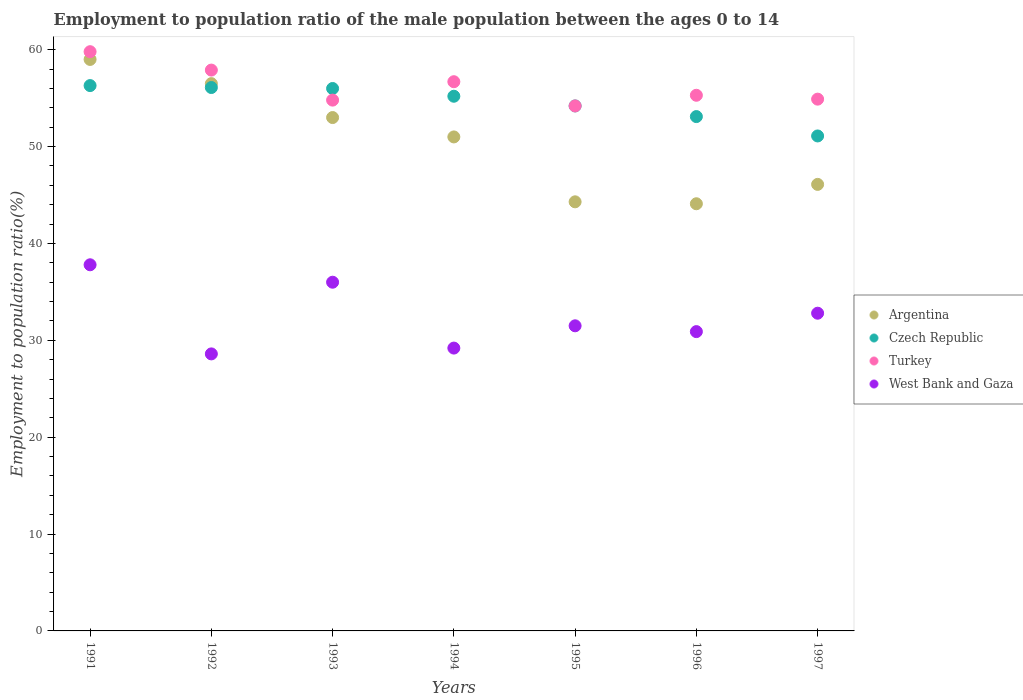How many different coloured dotlines are there?
Your answer should be compact. 4. Is the number of dotlines equal to the number of legend labels?
Give a very brief answer. Yes. What is the employment to population ratio in Turkey in 1996?
Your answer should be compact. 55.3. Across all years, what is the maximum employment to population ratio in Turkey?
Ensure brevity in your answer.  59.8. Across all years, what is the minimum employment to population ratio in Argentina?
Your answer should be compact. 44.1. In which year was the employment to population ratio in Turkey maximum?
Provide a succinct answer. 1991. What is the total employment to population ratio in Turkey in the graph?
Offer a terse response. 393.6. What is the difference between the employment to population ratio in Czech Republic in 1993 and the employment to population ratio in Turkey in 1995?
Offer a terse response. 1.8. What is the average employment to population ratio in Czech Republic per year?
Provide a succinct answer. 54.57. In the year 1996, what is the difference between the employment to population ratio in Czech Republic and employment to population ratio in West Bank and Gaza?
Offer a very short reply. 22.2. What is the ratio of the employment to population ratio in West Bank and Gaza in 1991 to that in 1992?
Your response must be concise. 1.32. Is the employment to population ratio in Turkey in 1993 less than that in 1997?
Your response must be concise. Yes. What is the difference between the highest and the second highest employment to population ratio in Turkey?
Provide a succinct answer. 1.9. What is the difference between the highest and the lowest employment to population ratio in Turkey?
Provide a succinct answer. 5.6. In how many years, is the employment to population ratio in West Bank and Gaza greater than the average employment to population ratio in West Bank and Gaza taken over all years?
Your answer should be very brief. 3. Does the employment to population ratio in West Bank and Gaza monotonically increase over the years?
Keep it short and to the point. No. Is the employment to population ratio in West Bank and Gaza strictly greater than the employment to population ratio in Czech Republic over the years?
Your answer should be compact. No. Is the employment to population ratio in West Bank and Gaza strictly less than the employment to population ratio in Argentina over the years?
Ensure brevity in your answer.  Yes. How many years are there in the graph?
Your response must be concise. 7. Are the values on the major ticks of Y-axis written in scientific E-notation?
Offer a very short reply. No. Does the graph contain any zero values?
Make the answer very short. No. Does the graph contain grids?
Your answer should be compact. No. Where does the legend appear in the graph?
Make the answer very short. Center right. How many legend labels are there?
Provide a succinct answer. 4. How are the legend labels stacked?
Offer a very short reply. Vertical. What is the title of the graph?
Provide a short and direct response. Employment to population ratio of the male population between the ages 0 to 14. Does "Jordan" appear as one of the legend labels in the graph?
Give a very brief answer. No. What is the Employment to population ratio(%) of Argentina in 1991?
Your answer should be compact. 59. What is the Employment to population ratio(%) in Czech Republic in 1991?
Your response must be concise. 56.3. What is the Employment to population ratio(%) in Turkey in 1991?
Make the answer very short. 59.8. What is the Employment to population ratio(%) in West Bank and Gaza in 1991?
Give a very brief answer. 37.8. What is the Employment to population ratio(%) in Argentina in 1992?
Make the answer very short. 56.5. What is the Employment to population ratio(%) in Czech Republic in 1992?
Keep it short and to the point. 56.1. What is the Employment to population ratio(%) of Turkey in 1992?
Your response must be concise. 57.9. What is the Employment to population ratio(%) in West Bank and Gaza in 1992?
Provide a short and direct response. 28.6. What is the Employment to population ratio(%) of Argentina in 1993?
Make the answer very short. 53. What is the Employment to population ratio(%) of Turkey in 1993?
Give a very brief answer. 54.8. What is the Employment to population ratio(%) in West Bank and Gaza in 1993?
Your answer should be very brief. 36. What is the Employment to population ratio(%) in Czech Republic in 1994?
Ensure brevity in your answer.  55.2. What is the Employment to population ratio(%) of Turkey in 1994?
Offer a terse response. 56.7. What is the Employment to population ratio(%) of West Bank and Gaza in 1994?
Provide a short and direct response. 29.2. What is the Employment to population ratio(%) in Argentina in 1995?
Offer a very short reply. 44.3. What is the Employment to population ratio(%) in Czech Republic in 1995?
Keep it short and to the point. 54.2. What is the Employment to population ratio(%) of Turkey in 1995?
Ensure brevity in your answer.  54.2. What is the Employment to population ratio(%) of West Bank and Gaza in 1995?
Offer a terse response. 31.5. What is the Employment to population ratio(%) in Argentina in 1996?
Provide a succinct answer. 44.1. What is the Employment to population ratio(%) of Czech Republic in 1996?
Offer a terse response. 53.1. What is the Employment to population ratio(%) of Turkey in 1996?
Ensure brevity in your answer.  55.3. What is the Employment to population ratio(%) of West Bank and Gaza in 1996?
Provide a short and direct response. 30.9. What is the Employment to population ratio(%) of Argentina in 1997?
Offer a terse response. 46.1. What is the Employment to population ratio(%) of Czech Republic in 1997?
Ensure brevity in your answer.  51.1. What is the Employment to population ratio(%) in Turkey in 1997?
Offer a very short reply. 54.9. What is the Employment to population ratio(%) of West Bank and Gaza in 1997?
Provide a short and direct response. 32.8. Across all years, what is the maximum Employment to population ratio(%) in Czech Republic?
Provide a short and direct response. 56.3. Across all years, what is the maximum Employment to population ratio(%) of Turkey?
Your answer should be compact. 59.8. Across all years, what is the maximum Employment to population ratio(%) of West Bank and Gaza?
Keep it short and to the point. 37.8. Across all years, what is the minimum Employment to population ratio(%) in Argentina?
Ensure brevity in your answer.  44.1. Across all years, what is the minimum Employment to population ratio(%) in Czech Republic?
Your answer should be compact. 51.1. Across all years, what is the minimum Employment to population ratio(%) in Turkey?
Ensure brevity in your answer.  54.2. Across all years, what is the minimum Employment to population ratio(%) in West Bank and Gaza?
Make the answer very short. 28.6. What is the total Employment to population ratio(%) in Argentina in the graph?
Offer a very short reply. 354. What is the total Employment to population ratio(%) of Czech Republic in the graph?
Your answer should be very brief. 382. What is the total Employment to population ratio(%) of Turkey in the graph?
Offer a terse response. 393.6. What is the total Employment to population ratio(%) of West Bank and Gaza in the graph?
Keep it short and to the point. 226.8. What is the difference between the Employment to population ratio(%) in Argentina in 1991 and that in 1992?
Your response must be concise. 2.5. What is the difference between the Employment to population ratio(%) of Czech Republic in 1991 and that in 1992?
Offer a very short reply. 0.2. What is the difference between the Employment to population ratio(%) of Turkey in 1991 and that in 1992?
Give a very brief answer. 1.9. What is the difference between the Employment to population ratio(%) of West Bank and Gaza in 1991 and that in 1992?
Keep it short and to the point. 9.2. What is the difference between the Employment to population ratio(%) of Argentina in 1991 and that in 1993?
Offer a terse response. 6. What is the difference between the Employment to population ratio(%) in Czech Republic in 1991 and that in 1993?
Offer a very short reply. 0.3. What is the difference between the Employment to population ratio(%) in Turkey in 1991 and that in 1993?
Your answer should be compact. 5. What is the difference between the Employment to population ratio(%) in West Bank and Gaza in 1991 and that in 1993?
Provide a succinct answer. 1.8. What is the difference between the Employment to population ratio(%) of Argentina in 1991 and that in 1994?
Offer a terse response. 8. What is the difference between the Employment to population ratio(%) of Argentina in 1991 and that in 1995?
Ensure brevity in your answer.  14.7. What is the difference between the Employment to population ratio(%) of Czech Republic in 1991 and that in 1995?
Provide a succinct answer. 2.1. What is the difference between the Employment to population ratio(%) of Argentina in 1991 and that in 1996?
Your answer should be compact. 14.9. What is the difference between the Employment to population ratio(%) of Czech Republic in 1991 and that in 1996?
Your answer should be compact. 3.2. What is the difference between the Employment to population ratio(%) in Turkey in 1991 and that in 1996?
Your answer should be compact. 4.5. What is the difference between the Employment to population ratio(%) in Argentina in 1991 and that in 1997?
Your answer should be very brief. 12.9. What is the difference between the Employment to population ratio(%) of Czech Republic in 1991 and that in 1997?
Give a very brief answer. 5.2. What is the difference between the Employment to population ratio(%) of Argentina in 1992 and that in 1993?
Ensure brevity in your answer.  3.5. What is the difference between the Employment to population ratio(%) in Czech Republic in 1992 and that in 1993?
Offer a terse response. 0.1. What is the difference between the Employment to population ratio(%) in Turkey in 1992 and that in 1993?
Provide a succinct answer. 3.1. What is the difference between the Employment to population ratio(%) in West Bank and Gaza in 1992 and that in 1993?
Provide a succinct answer. -7.4. What is the difference between the Employment to population ratio(%) in West Bank and Gaza in 1992 and that in 1994?
Your answer should be very brief. -0.6. What is the difference between the Employment to population ratio(%) in West Bank and Gaza in 1992 and that in 1995?
Provide a short and direct response. -2.9. What is the difference between the Employment to population ratio(%) in Argentina in 1992 and that in 1996?
Offer a terse response. 12.4. What is the difference between the Employment to population ratio(%) of Turkey in 1992 and that in 1996?
Ensure brevity in your answer.  2.6. What is the difference between the Employment to population ratio(%) in West Bank and Gaza in 1992 and that in 1996?
Ensure brevity in your answer.  -2.3. What is the difference between the Employment to population ratio(%) of Czech Republic in 1992 and that in 1997?
Make the answer very short. 5. What is the difference between the Employment to population ratio(%) in West Bank and Gaza in 1992 and that in 1997?
Ensure brevity in your answer.  -4.2. What is the difference between the Employment to population ratio(%) in Czech Republic in 1993 and that in 1994?
Provide a short and direct response. 0.8. What is the difference between the Employment to population ratio(%) of Argentina in 1993 and that in 1995?
Offer a terse response. 8.7. What is the difference between the Employment to population ratio(%) of Argentina in 1993 and that in 1997?
Your response must be concise. 6.9. What is the difference between the Employment to population ratio(%) in Czech Republic in 1993 and that in 1997?
Your answer should be very brief. 4.9. What is the difference between the Employment to population ratio(%) of Turkey in 1993 and that in 1997?
Ensure brevity in your answer.  -0.1. What is the difference between the Employment to population ratio(%) of Argentina in 1994 and that in 1995?
Keep it short and to the point. 6.7. What is the difference between the Employment to population ratio(%) in Czech Republic in 1994 and that in 1995?
Your response must be concise. 1. What is the difference between the Employment to population ratio(%) of West Bank and Gaza in 1994 and that in 1995?
Your response must be concise. -2.3. What is the difference between the Employment to population ratio(%) in Turkey in 1994 and that in 1996?
Provide a succinct answer. 1.4. What is the difference between the Employment to population ratio(%) in West Bank and Gaza in 1994 and that in 1996?
Make the answer very short. -1.7. What is the difference between the Employment to population ratio(%) of Argentina in 1994 and that in 1997?
Make the answer very short. 4.9. What is the difference between the Employment to population ratio(%) of West Bank and Gaza in 1994 and that in 1997?
Give a very brief answer. -3.6. What is the difference between the Employment to population ratio(%) in West Bank and Gaza in 1995 and that in 1996?
Give a very brief answer. 0.6. What is the difference between the Employment to population ratio(%) of Argentina in 1995 and that in 1997?
Provide a short and direct response. -1.8. What is the difference between the Employment to population ratio(%) of West Bank and Gaza in 1995 and that in 1997?
Your answer should be very brief. -1.3. What is the difference between the Employment to population ratio(%) of Turkey in 1996 and that in 1997?
Offer a very short reply. 0.4. What is the difference between the Employment to population ratio(%) in Argentina in 1991 and the Employment to population ratio(%) in Czech Republic in 1992?
Offer a very short reply. 2.9. What is the difference between the Employment to population ratio(%) in Argentina in 1991 and the Employment to population ratio(%) in West Bank and Gaza in 1992?
Offer a very short reply. 30.4. What is the difference between the Employment to population ratio(%) of Czech Republic in 1991 and the Employment to population ratio(%) of West Bank and Gaza in 1992?
Ensure brevity in your answer.  27.7. What is the difference between the Employment to population ratio(%) of Turkey in 1991 and the Employment to population ratio(%) of West Bank and Gaza in 1992?
Give a very brief answer. 31.2. What is the difference between the Employment to population ratio(%) of Argentina in 1991 and the Employment to population ratio(%) of Czech Republic in 1993?
Your response must be concise. 3. What is the difference between the Employment to population ratio(%) of Argentina in 1991 and the Employment to population ratio(%) of Turkey in 1993?
Offer a very short reply. 4.2. What is the difference between the Employment to population ratio(%) in Czech Republic in 1991 and the Employment to population ratio(%) in Turkey in 1993?
Make the answer very short. 1.5. What is the difference between the Employment to population ratio(%) in Czech Republic in 1991 and the Employment to population ratio(%) in West Bank and Gaza in 1993?
Keep it short and to the point. 20.3. What is the difference between the Employment to population ratio(%) of Turkey in 1991 and the Employment to population ratio(%) of West Bank and Gaza in 1993?
Keep it short and to the point. 23.8. What is the difference between the Employment to population ratio(%) of Argentina in 1991 and the Employment to population ratio(%) of West Bank and Gaza in 1994?
Offer a terse response. 29.8. What is the difference between the Employment to population ratio(%) in Czech Republic in 1991 and the Employment to population ratio(%) in Turkey in 1994?
Your answer should be very brief. -0.4. What is the difference between the Employment to population ratio(%) in Czech Republic in 1991 and the Employment to population ratio(%) in West Bank and Gaza in 1994?
Provide a short and direct response. 27.1. What is the difference between the Employment to population ratio(%) of Turkey in 1991 and the Employment to population ratio(%) of West Bank and Gaza in 1994?
Your answer should be very brief. 30.6. What is the difference between the Employment to population ratio(%) of Argentina in 1991 and the Employment to population ratio(%) of West Bank and Gaza in 1995?
Your answer should be very brief. 27.5. What is the difference between the Employment to population ratio(%) of Czech Republic in 1991 and the Employment to population ratio(%) of West Bank and Gaza in 1995?
Offer a terse response. 24.8. What is the difference between the Employment to population ratio(%) of Turkey in 1991 and the Employment to population ratio(%) of West Bank and Gaza in 1995?
Offer a terse response. 28.3. What is the difference between the Employment to population ratio(%) of Argentina in 1991 and the Employment to population ratio(%) of Czech Republic in 1996?
Make the answer very short. 5.9. What is the difference between the Employment to population ratio(%) in Argentina in 1991 and the Employment to population ratio(%) in Turkey in 1996?
Provide a short and direct response. 3.7. What is the difference between the Employment to population ratio(%) in Argentina in 1991 and the Employment to population ratio(%) in West Bank and Gaza in 1996?
Provide a succinct answer. 28.1. What is the difference between the Employment to population ratio(%) in Czech Republic in 1991 and the Employment to population ratio(%) in Turkey in 1996?
Your answer should be very brief. 1. What is the difference between the Employment to population ratio(%) in Czech Republic in 1991 and the Employment to population ratio(%) in West Bank and Gaza in 1996?
Your answer should be compact. 25.4. What is the difference between the Employment to population ratio(%) of Turkey in 1991 and the Employment to population ratio(%) of West Bank and Gaza in 1996?
Offer a very short reply. 28.9. What is the difference between the Employment to population ratio(%) in Argentina in 1991 and the Employment to population ratio(%) in Turkey in 1997?
Your answer should be compact. 4.1. What is the difference between the Employment to population ratio(%) of Argentina in 1991 and the Employment to population ratio(%) of West Bank and Gaza in 1997?
Keep it short and to the point. 26.2. What is the difference between the Employment to population ratio(%) in Czech Republic in 1991 and the Employment to population ratio(%) in Turkey in 1997?
Keep it short and to the point. 1.4. What is the difference between the Employment to population ratio(%) in Argentina in 1992 and the Employment to population ratio(%) in Czech Republic in 1993?
Provide a succinct answer. 0.5. What is the difference between the Employment to population ratio(%) of Argentina in 1992 and the Employment to population ratio(%) of Turkey in 1993?
Offer a very short reply. 1.7. What is the difference between the Employment to population ratio(%) of Czech Republic in 1992 and the Employment to population ratio(%) of Turkey in 1993?
Keep it short and to the point. 1.3. What is the difference between the Employment to population ratio(%) of Czech Republic in 1992 and the Employment to population ratio(%) of West Bank and Gaza in 1993?
Provide a short and direct response. 20.1. What is the difference between the Employment to population ratio(%) in Turkey in 1992 and the Employment to population ratio(%) in West Bank and Gaza in 1993?
Your response must be concise. 21.9. What is the difference between the Employment to population ratio(%) of Argentina in 1992 and the Employment to population ratio(%) of West Bank and Gaza in 1994?
Ensure brevity in your answer.  27.3. What is the difference between the Employment to population ratio(%) in Czech Republic in 1992 and the Employment to population ratio(%) in West Bank and Gaza in 1994?
Provide a succinct answer. 26.9. What is the difference between the Employment to population ratio(%) in Turkey in 1992 and the Employment to population ratio(%) in West Bank and Gaza in 1994?
Your response must be concise. 28.7. What is the difference between the Employment to population ratio(%) in Czech Republic in 1992 and the Employment to population ratio(%) in West Bank and Gaza in 1995?
Offer a terse response. 24.6. What is the difference between the Employment to population ratio(%) of Turkey in 1992 and the Employment to population ratio(%) of West Bank and Gaza in 1995?
Offer a terse response. 26.4. What is the difference between the Employment to population ratio(%) in Argentina in 1992 and the Employment to population ratio(%) in West Bank and Gaza in 1996?
Your answer should be compact. 25.6. What is the difference between the Employment to population ratio(%) of Czech Republic in 1992 and the Employment to population ratio(%) of Turkey in 1996?
Provide a short and direct response. 0.8. What is the difference between the Employment to population ratio(%) in Czech Republic in 1992 and the Employment to population ratio(%) in West Bank and Gaza in 1996?
Offer a terse response. 25.2. What is the difference between the Employment to population ratio(%) of Turkey in 1992 and the Employment to population ratio(%) of West Bank and Gaza in 1996?
Your answer should be very brief. 27. What is the difference between the Employment to population ratio(%) in Argentina in 1992 and the Employment to population ratio(%) in Czech Republic in 1997?
Ensure brevity in your answer.  5.4. What is the difference between the Employment to population ratio(%) in Argentina in 1992 and the Employment to population ratio(%) in West Bank and Gaza in 1997?
Ensure brevity in your answer.  23.7. What is the difference between the Employment to population ratio(%) in Czech Republic in 1992 and the Employment to population ratio(%) in Turkey in 1997?
Keep it short and to the point. 1.2. What is the difference between the Employment to population ratio(%) of Czech Republic in 1992 and the Employment to population ratio(%) of West Bank and Gaza in 1997?
Offer a very short reply. 23.3. What is the difference between the Employment to population ratio(%) of Turkey in 1992 and the Employment to population ratio(%) of West Bank and Gaza in 1997?
Provide a succinct answer. 25.1. What is the difference between the Employment to population ratio(%) in Argentina in 1993 and the Employment to population ratio(%) in Czech Republic in 1994?
Give a very brief answer. -2.2. What is the difference between the Employment to population ratio(%) in Argentina in 1993 and the Employment to population ratio(%) in West Bank and Gaza in 1994?
Keep it short and to the point. 23.8. What is the difference between the Employment to population ratio(%) in Czech Republic in 1993 and the Employment to population ratio(%) in Turkey in 1994?
Ensure brevity in your answer.  -0.7. What is the difference between the Employment to population ratio(%) of Czech Republic in 1993 and the Employment to population ratio(%) of West Bank and Gaza in 1994?
Give a very brief answer. 26.8. What is the difference between the Employment to population ratio(%) in Turkey in 1993 and the Employment to population ratio(%) in West Bank and Gaza in 1994?
Provide a succinct answer. 25.6. What is the difference between the Employment to population ratio(%) in Argentina in 1993 and the Employment to population ratio(%) in Turkey in 1995?
Offer a terse response. -1.2. What is the difference between the Employment to population ratio(%) of Turkey in 1993 and the Employment to population ratio(%) of West Bank and Gaza in 1995?
Your answer should be very brief. 23.3. What is the difference between the Employment to population ratio(%) of Argentina in 1993 and the Employment to population ratio(%) of Czech Republic in 1996?
Offer a very short reply. -0.1. What is the difference between the Employment to population ratio(%) of Argentina in 1993 and the Employment to population ratio(%) of West Bank and Gaza in 1996?
Provide a short and direct response. 22.1. What is the difference between the Employment to population ratio(%) of Czech Republic in 1993 and the Employment to population ratio(%) of Turkey in 1996?
Make the answer very short. 0.7. What is the difference between the Employment to population ratio(%) in Czech Republic in 1993 and the Employment to population ratio(%) in West Bank and Gaza in 1996?
Give a very brief answer. 25.1. What is the difference between the Employment to population ratio(%) of Turkey in 1993 and the Employment to population ratio(%) of West Bank and Gaza in 1996?
Your answer should be compact. 23.9. What is the difference between the Employment to population ratio(%) of Argentina in 1993 and the Employment to population ratio(%) of Czech Republic in 1997?
Make the answer very short. 1.9. What is the difference between the Employment to population ratio(%) in Argentina in 1993 and the Employment to population ratio(%) in West Bank and Gaza in 1997?
Your answer should be compact. 20.2. What is the difference between the Employment to population ratio(%) of Czech Republic in 1993 and the Employment to population ratio(%) of West Bank and Gaza in 1997?
Your answer should be compact. 23.2. What is the difference between the Employment to population ratio(%) of Argentina in 1994 and the Employment to population ratio(%) of Turkey in 1995?
Your answer should be very brief. -3.2. What is the difference between the Employment to population ratio(%) of Czech Republic in 1994 and the Employment to population ratio(%) of West Bank and Gaza in 1995?
Provide a short and direct response. 23.7. What is the difference between the Employment to population ratio(%) of Turkey in 1994 and the Employment to population ratio(%) of West Bank and Gaza in 1995?
Provide a succinct answer. 25.2. What is the difference between the Employment to population ratio(%) in Argentina in 1994 and the Employment to population ratio(%) in Czech Republic in 1996?
Your answer should be very brief. -2.1. What is the difference between the Employment to population ratio(%) in Argentina in 1994 and the Employment to population ratio(%) in Turkey in 1996?
Provide a short and direct response. -4.3. What is the difference between the Employment to population ratio(%) in Argentina in 1994 and the Employment to population ratio(%) in West Bank and Gaza in 1996?
Provide a succinct answer. 20.1. What is the difference between the Employment to population ratio(%) in Czech Republic in 1994 and the Employment to population ratio(%) in West Bank and Gaza in 1996?
Provide a succinct answer. 24.3. What is the difference between the Employment to population ratio(%) of Turkey in 1994 and the Employment to population ratio(%) of West Bank and Gaza in 1996?
Offer a terse response. 25.8. What is the difference between the Employment to population ratio(%) in Argentina in 1994 and the Employment to population ratio(%) in Czech Republic in 1997?
Offer a terse response. -0.1. What is the difference between the Employment to population ratio(%) in Argentina in 1994 and the Employment to population ratio(%) in West Bank and Gaza in 1997?
Provide a succinct answer. 18.2. What is the difference between the Employment to population ratio(%) of Czech Republic in 1994 and the Employment to population ratio(%) of Turkey in 1997?
Your answer should be very brief. 0.3. What is the difference between the Employment to population ratio(%) in Czech Republic in 1994 and the Employment to population ratio(%) in West Bank and Gaza in 1997?
Offer a terse response. 22.4. What is the difference between the Employment to population ratio(%) in Turkey in 1994 and the Employment to population ratio(%) in West Bank and Gaza in 1997?
Make the answer very short. 23.9. What is the difference between the Employment to population ratio(%) in Argentina in 1995 and the Employment to population ratio(%) in Czech Republic in 1996?
Ensure brevity in your answer.  -8.8. What is the difference between the Employment to population ratio(%) of Argentina in 1995 and the Employment to population ratio(%) of Turkey in 1996?
Your response must be concise. -11. What is the difference between the Employment to population ratio(%) of Argentina in 1995 and the Employment to population ratio(%) of West Bank and Gaza in 1996?
Provide a succinct answer. 13.4. What is the difference between the Employment to population ratio(%) in Czech Republic in 1995 and the Employment to population ratio(%) in Turkey in 1996?
Provide a short and direct response. -1.1. What is the difference between the Employment to population ratio(%) of Czech Republic in 1995 and the Employment to population ratio(%) of West Bank and Gaza in 1996?
Offer a terse response. 23.3. What is the difference between the Employment to population ratio(%) in Turkey in 1995 and the Employment to population ratio(%) in West Bank and Gaza in 1996?
Make the answer very short. 23.3. What is the difference between the Employment to population ratio(%) in Argentina in 1995 and the Employment to population ratio(%) in Czech Republic in 1997?
Give a very brief answer. -6.8. What is the difference between the Employment to population ratio(%) of Argentina in 1995 and the Employment to population ratio(%) of West Bank and Gaza in 1997?
Keep it short and to the point. 11.5. What is the difference between the Employment to population ratio(%) of Czech Republic in 1995 and the Employment to population ratio(%) of West Bank and Gaza in 1997?
Your response must be concise. 21.4. What is the difference between the Employment to population ratio(%) of Turkey in 1995 and the Employment to population ratio(%) of West Bank and Gaza in 1997?
Ensure brevity in your answer.  21.4. What is the difference between the Employment to population ratio(%) in Argentina in 1996 and the Employment to population ratio(%) in Turkey in 1997?
Your answer should be very brief. -10.8. What is the difference between the Employment to population ratio(%) in Czech Republic in 1996 and the Employment to population ratio(%) in Turkey in 1997?
Provide a short and direct response. -1.8. What is the difference between the Employment to population ratio(%) in Czech Republic in 1996 and the Employment to population ratio(%) in West Bank and Gaza in 1997?
Offer a very short reply. 20.3. What is the average Employment to population ratio(%) in Argentina per year?
Offer a very short reply. 50.57. What is the average Employment to population ratio(%) in Czech Republic per year?
Your answer should be compact. 54.57. What is the average Employment to population ratio(%) of Turkey per year?
Provide a short and direct response. 56.23. What is the average Employment to population ratio(%) in West Bank and Gaza per year?
Ensure brevity in your answer.  32.4. In the year 1991, what is the difference between the Employment to population ratio(%) in Argentina and Employment to population ratio(%) in Czech Republic?
Offer a terse response. 2.7. In the year 1991, what is the difference between the Employment to population ratio(%) of Argentina and Employment to population ratio(%) of Turkey?
Offer a very short reply. -0.8. In the year 1991, what is the difference between the Employment to population ratio(%) of Argentina and Employment to population ratio(%) of West Bank and Gaza?
Give a very brief answer. 21.2. In the year 1991, what is the difference between the Employment to population ratio(%) of Czech Republic and Employment to population ratio(%) of Turkey?
Provide a short and direct response. -3.5. In the year 1991, what is the difference between the Employment to population ratio(%) in Czech Republic and Employment to population ratio(%) in West Bank and Gaza?
Ensure brevity in your answer.  18.5. In the year 1991, what is the difference between the Employment to population ratio(%) in Turkey and Employment to population ratio(%) in West Bank and Gaza?
Offer a very short reply. 22. In the year 1992, what is the difference between the Employment to population ratio(%) in Argentina and Employment to population ratio(%) in West Bank and Gaza?
Offer a terse response. 27.9. In the year 1992, what is the difference between the Employment to population ratio(%) of Czech Republic and Employment to population ratio(%) of Turkey?
Give a very brief answer. -1.8. In the year 1992, what is the difference between the Employment to population ratio(%) of Czech Republic and Employment to population ratio(%) of West Bank and Gaza?
Offer a very short reply. 27.5. In the year 1992, what is the difference between the Employment to population ratio(%) of Turkey and Employment to population ratio(%) of West Bank and Gaza?
Ensure brevity in your answer.  29.3. In the year 1993, what is the difference between the Employment to population ratio(%) of Argentina and Employment to population ratio(%) of Czech Republic?
Offer a very short reply. -3. In the year 1993, what is the difference between the Employment to population ratio(%) of Argentina and Employment to population ratio(%) of Turkey?
Your response must be concise. -1.8. In the year 1994, what is the difference between the Employment to population ratio(%) of Argentina and Employment to population ratio(%) of Czech Republic?
Make the answer very short. -4.2. In the year 1994, what is the difference between the Employment to population ratio(%) in Argentina and Employment to population ratio(%) in Turkey?
Give a very brief answer. -5.7. In the year 1994, what is the difference between the Employment to population ratio(%) of Argentina and Employment to population ratio(%) of West Bank and Gaza?
Your answer should be compact. 21.8. In the year 1994, what is the difference between the Employment to population ratio(%) of Czech Republic and Employment to population ratio(%) of Turkey?
Provide a succinct answer. -1.5. In the year 1994, what is the difference between the Employment to population ratio(%) of Turkey and Employment to population ratio(%) of West Bank and Gaza?
Your response must be concise. 27.5. In the year 1995, what is the difference between the Employment to population ratio(%) of Argentina and Employment to population ratio(%) of Czech Republic?
Offer a terse response. -9.9. In the year 1995, what is the difference between the Employment to population ratio(%) of Czech Republic and Employment to population ratio(%) of West Bank and Gaza?
Your response must be concise. 22.7. In the year 1995, what is the difference between the Employment to population ratio(%) of Turkey and Employment to population ratio(%) of West Bank and Gaza?
Offer a terse response. 22.7. In the year 1996, what is the difference between the Employment to population ratio(%) of Argentina and Employment to population ratio(%) of Turkey?
Your answer should be very brief. -11.2. In the year 1996, what is the difference between the Employment to population ratio(%) in Czech Republic and Employment to population ratio(%) in West Bank and Gaza?
Make the answer very short. 22.2. In the year 1996, what is the difference between the Employment to population ratio(%) of Turkey and Employment to population ratio(%) of West Bank and Gaza?
Make the answer very short. 24.4. In the year 1997, what is the difference between the Employment to population ratio(%) in Argentina and Employment to population ratio(%) in Czech Republic?
Keep it short and to the point. -5. In the year 1997, what is the difference between the Employment to population ratio(%) in Argentina and Employment to population ratio(%) in Turkey?
Ensure brevity in your answer.  -8.8. In the year 1997, what is the difference between the Employment to population ratio(%) in Argentina and Employment to population ratio(%) in West Bank and Gaza?
Offer a terse response. 13.3. In the year 1997, what is the difference between the Employment to population ratio(%) of Turkey and Employment to population ratio(%) of West Bank and Gaza?
Ensure brevity in your answer.  22.1. What is the ratio of the Employment to population ratio(%) of Argentina in 1991 to that in 1992?
Provide a short and direct response. 1.04. What is the ratio of the Employment to population ratio(%) of Turkey in 1991 to that in 1992?
Make the answer very short. 1.03. What is the ratio of the Employment to population ratio(%) in West Bank and Gaza in 1991 to that in 1992?
Give a very brief answer. 1.32. What is the ratio of the Employment to population ratio(%) in Argentina in 1991 to that in 1993?
Give a very brief answer. 1.11. What is the ratio of the Employment to population ratio(%) in Czech Republic in 1991 to that in 1993?
Your answer should be very brief. 1.01. What is the ratio of the Employment to population ratio(%) of Turkey in 1991 to that in 1993?
Give a very brief answer. 1.09. What is the ratio of the Employment to population ratio(%) in Argentina in 1991 to that in 1994?
Offer a terse response. 1.16. What is the ratio of the Employment to population ratio(%) in Czech Republic in 1991 to that in 1994?
Your response must be concise. 1.02. What is the ratio of the Employment to population ratio(%) of Turkey in 1991 to that in 1994?
Your answer should be compact. 1.05. What is the ratio of the Employment to population ratio(%) in West Bank and Gaza in 1991 to that in 1994?
Offer a very short reply. 1.29. What is the ratio of the Employment to population ratio(%) in Argentina in 1991 to that in 1995?
Your response must be concise. 1.33. What is the ratio of the Employment to population ratio(%) in Czech Republic in 1991 to that in 1995?
Give a very brief answer. 1.04. What is the ratio of the Employment to population ratio(%) of Turkey in 1991 to that in 1995?
Offer a very short reply. 1.1. What is the ratio of the Employment to population ratio(%) of Argentina in 1991 to that in 1996?
Offer a very short reply. 1.34. What is the ratio of the Employment to population ratio(%) in Czech Republic in 1991 to that in 1996?
Your answer should be very brief. 1.06. What is the ratio of the Employment to population ratio(%) of Turkey in 1991 to that in 1996?
Give a very brief answer. 1.08. What is the ratio of the Employment to population ratio(%) in West Bank and Gaza in 1991 to that in 1996?
Provide a short and direct response. 1.22. What is the ratio of the Employment to population ratio(%) of Argentina in 1991 to that in 1997?
Keep it short and to the point. 1.28. What is the ratio of the Employment to population ratio(%) in Czech Republic in 1991 to that in 1997?
Provide a short and direct response. 1.1. What is the ratio of the Employment to population ratio(%) in Turkey in 1991 to that in 1997?
Ensure brevity in your answer.  1.09. What is the ratio of the Employment to population ratio(%) of West Bank and Gaza in 1991 to that in 1997?
Keep it short and to the point. 1.15. What is the ratio of the Employment to population ratio(%) in Argentina in 1992 to that in 1993?
Offer a very short reply. 1.07. What is the ratio of the Employment to population ratio(%) of Czech Republic in 1992 to that in 1993?
Provide a short and direct response. 1. What is the ratio of the Employment to population ratio(%) of Turkey in 1992 to that in 1993?
Give a very brief answer. 1.06. What is the ratio of the Employment to population ratio(%) of West Bank and Gaza in 1992 to that in 1993?
Ensure brevity in your answer.  0.79. What is the ratio of the Employment to population ratio(%) in Argentina in 1992 to that in 1994?
Offer a very short reply. 1.11. What is the ratio of the Employment to population ratio(%) in Czech Republic in 1992 to that in 1994?
Make the answer very short. 1.02. What is the ratio of the Employment to population ratio(%) in Turkey in 1992 to that in 1994?
Your response must be concise. 1.02. What is the ratio of the Employment to population ratio(%) of West Bank and Gaza in 1992 to that in 1994?
Offer a very short reply. 0.98. What is the ratio of the Employment to population ratio(%) of Argentina in 1992 to that in 1995?
Ensure brevity in your answer.  1.28. What is the ratio of the Employment to population ratio(%) of Czech Republic in 1992 to that in 1995?
Ensure brevity in your answer.  1.04. What is the ratio of the Employment to population ratio(%) of Turkey in 1992 to that in 1995?
Your answer should be very brief. 1.07. What is the ratio of the Employment to population ratio(%) of West Bank and Gaza in 1992 to that in 1995?
Provide a succinct answer. 0.91. What is the ratio of the Employment to population ratio(%) in Argentina in 1992 to that in 1996?
Make the answer very short. 1.28. What is the ratio of the Employment to population ratio(%) of Czech Republic in 1992 to that in 1996?
Keep it short and to the point. 1.06. What is the ratio of the Employment to population ratio(%) of Turkey in 1992 to that in 1996?
Ensure brevity in your answer.  1.05. What is the ratio of the Employment to population ratio(%) in West Bank and Gaza in 1992 to that in 1996?
Give a very brief answer. 0.93. What is the ratio of the Employment to population ratio(%) of Argentina in 1992 to that in 1997?
Your answer should be very brief. 1.23. What is the ratio of the Employment to population ratio(%) in Czech Republic in 1992 to that in 1997?
Give a very brief answer. 1.1. What is the ratio of the Employment to population ratio(%) of Turkey in 1992 to that in 1997?
Keep it short and to the point. 1.05. What is the ratio of the Employment to population ratio(%) in West Bank and Gaza in 1992 to that in 1997?
Give a very brief answer. 0.87. What is the ratio of the Employment to population ratio(%) in Argentina in 1993 to that in 1994?
Provide a short and direct response. 1.04. What is the ratio of the Employment to population ratio(%) in Czech Republic in 1993 to that in 1994?
Your answer should be very brief. 1.01. What is the ratio of the Employment to population ratio(%) in Turkey in 1993 to that in 1994?
Your answer should be compact. 0.97. What is the ratio of the Employment to population ratio(%) of West Bank and Gaza in 1993 to that in 1994?
Keep it short and to the point. 1.23. What is the ratio of the Employment to population ratio(%) in Argentina in 1993 to that in 1995?
Your answer should be compact. 1.2. What is the ratio of the Employment to population ratio(%) of Czech Republic in 1993 to that in 1995?
Offer a terse response. 1.03. What is the ratio of the Employment to population ratio(%) in Turkey in 1993 to that in 1995?
Provide a short and direct response. 1.01. What is the ratio of the Employment to population ratio(%) in Argentina in 1993 to that in 1996?
Make the answer very short. 1.2. What is the ratio of the Employment to population ratio(%) of Czech Republic in 1993 to that in 1996?
Ensure brevity in your answer.  1.05. What is the ratio of the Employment to population ratio(%) in West Bank and Gaza in 1993 to that in 1996?
Your answer should be compact. 1.17. What is the ratio of the Employment to population ratio(%) of Argentina in 1993 to that in 1997?
Keep it short and to the point. 1.15. What is the ratio of the Employment to population ratio(%) of Czech Republic in 1993 to that in 1997?
Your response must be concise. 1.1. What is the ratio of the Employment to population ratio(%) in Turkey in 1993 to that in 1997?
Your response must be concise. 1. What is the ratio of the Employment to population ratio(%) of West Bank and Gaza in 1993 to that in 1997?
Give a very brief answer. 1.1. What is the ratio of the Employment to population ratio(%) of Argentina in 1994 to that in 1995?
Give a very brief answer. 1.15. What is the ratio of the Employment to population ratio(%) in Czech Republic in 1994 to that in 1995?
Ensure brevity in your answer.  1.02. What is the ratio of the Employment to population ratio(%) of Turkey in 1994 to that in 1995?
Ensure brevity in your answer.  1.05. What is the ratio of the Employment to population ratio(%) in West Bank and Gaza in 1994 to that in 1995?
Provide a short and direct response. 0.93. What is the ratio of the Employment to population ratio(%) in Argentina in 1994 to that in 1996?
Provide a succinct answer. 1.16. What is the ratio of the Employment to population ratio(%) of Czech Republic in 1994 to that in 1996?
Keep it short and to the point. 1.04. What is the ratio of the Employment to population ratio(%) of Turkey in 1994 to that in 1996?
Your answer should be compact. 1.03. What is the ratio of the Employment to population ratio(%) of West Bank and Gaza in 1994 to that in 1996?
Provide a short and direct response. 0.94. What is the ratio of the Employment to population ratio(%) in Argentina in 1994 to that in 1997?
Provide a succinct answer. 1.11. What is the ratio of the Employment to population ratio(%) in Czech Republic in 1994 to that in 1997?
Your answer should be very brief. 1.08. What is the ratio of the Employment to population ratio(%) of Turkey in 1994 to that in 1997?
Your answer should be very brief. 1.03. What is the ratio of the Employment to population ratio(%) of West Bank and Gaza in 1994 to that in 1997?
Provide a short and direct response. 0.89. What is the ratio of the Employment to population ratio(%) in Argentina in 1995 to that in 1996?
Provide a short and direct response. 1. What is the ratio of the Employment to population ratio(%) in Czech Republic in 1995 to that in 1996?
Give a very brief answer. 1.02. What is the ratio of the Employment to population ratio(%) in Turkey in 1995 to that in 1996?
Your answer should be very brief. 0.98. What is the ratio of the Employment to population ratio(%) of West Bank and Gaza in 1995 to that in 1996?
Keep it short and to the point. 1.02. What is the ratio of the Employment to population ratio(%) in Czech Republic in 1995 to that in 1997?
Provide a succinct answer. 1.06. What is the ratio of the Employment to population ratio(%) in Turkey in 1995 to that in 1997?
Provide a short and direct response. 0.99. What is the ratio of the Employment to population ratio(%) of West Bank and Gaza in 1995 to that in 1997?
Your answer should be compact. 0.96. What is the ratio of the Employment to population ratio(%) of Argentina in 1996 to that in 1997?
Provide a succinct answer. 0.96. What is the ratio of the Employment to population ratio(%) in Czech Republic in 1996 to that in 1997?
Your answer should be compact. 1.04. What is the ratio of the Employment to population ratio(%) in Turkey in 1996 to that in 1997?
Keep it short and to the point. 1.01. What is the ratio of the Employment to population ratio(%) of West Bank and Gaza in 1996 to that in 1997?
Offer a terse response. 0.94. What is the difference between the highest and the second highest Employment to population ratio(%) in Argentina?
Offer a terse response. 2.5. What is the difference between the highest and the second highest Employment to population ratio(%) in Czech Republic?
Provide a succinct answer. 0.2. What is the difference between the highest and the lowest Employment to population ratio(%) of Czech Republic?
Provide a short and direct response. 5.2. What is the difference between the highest and the lowest Employment to population ratio(%) in Turkey?
Your response must be concise. 5.6. 